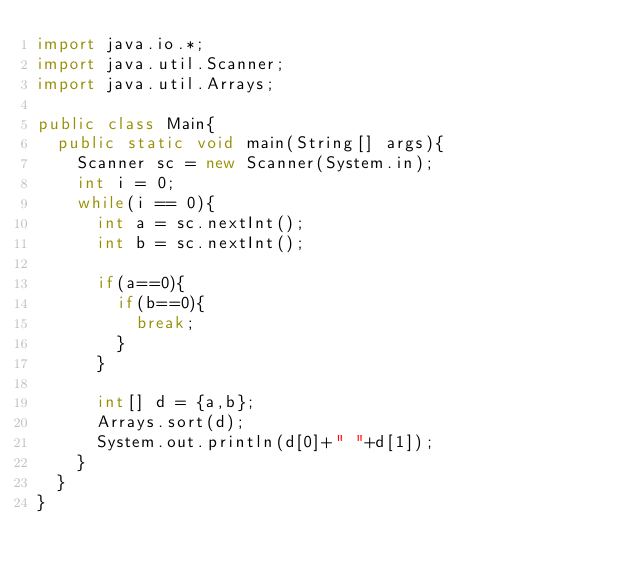Convert code to text. <code><loc_0><loc_0><loc_500><loc_500><_Java_>import java.io.*;
import java.util.Scanner;
import java.util.Arrays;

public class Main{
	public static void main(String[] args){
		Scanner sc = new Scanner(System.in);
		int i = 0;
		while(i == 0){
			int a = sc.nextInt();
			int b = sc.nextInt();
			
			if(a==0){
				if(b==0){
					break;
				}
			}
	
			int[] d = {a,b};
			Arrays.sort(d);
			System.out.println(d[0]+" "+d[1]);
		}
	}
}</code> 